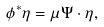Convert formula to latex. <formula><loc_0><loc_0><loc_500><loc_500>\phi ^ { * } \eta = \mu \Psi \cdot \eta ,</formula> 